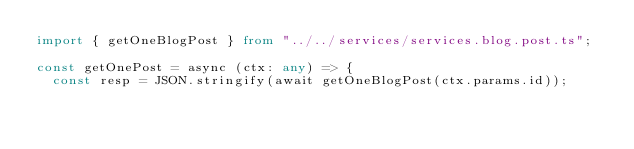<code> <loc_0><loc_0><loc_500><loc_500><_TypeScript_>import { getOneBlogPost } from "../../services/services.blog.post.ts";

const getOnePost = async (ctx: any) => {
  const resp = JSON.stringify(await getOneBlogPost(ctx.params.id));</code> 